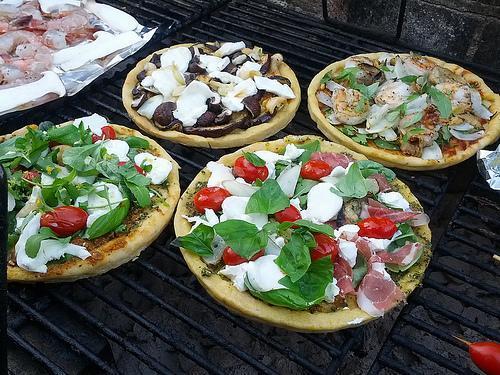How many grills are there?
Give a very brief answer. 1. 